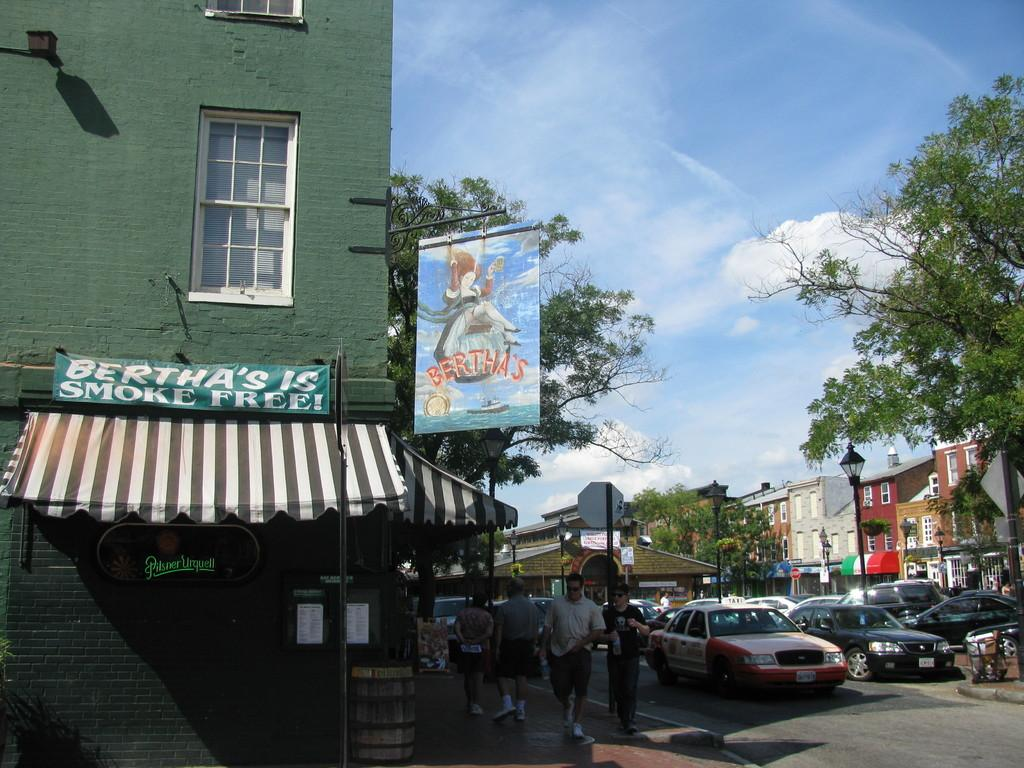<image>
Describe the image concisely. Berthas is a place that is outside with clouds above 